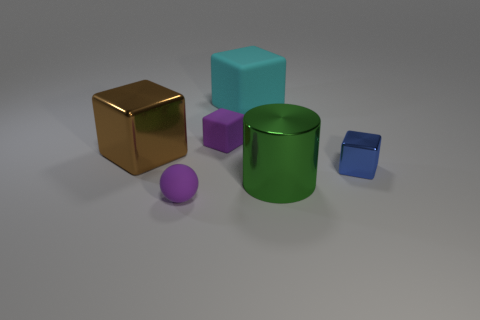Subtract 1 blocks. How many blocks are left? 3 Add 4 big cylinders. How many objects exist? 10 Subtract all cylinders. How many objects are left? 5 Subtract 0 cyan cylinders. How many objects are left? 6 Subtract all tiny brown things. Subtract all brown objects. How many objects are left? 5 Add 6 big brown blocks. How many big brown blocks are left? 7 Add 6 green metal cylinders. How many green metal cylinders exist? 7 